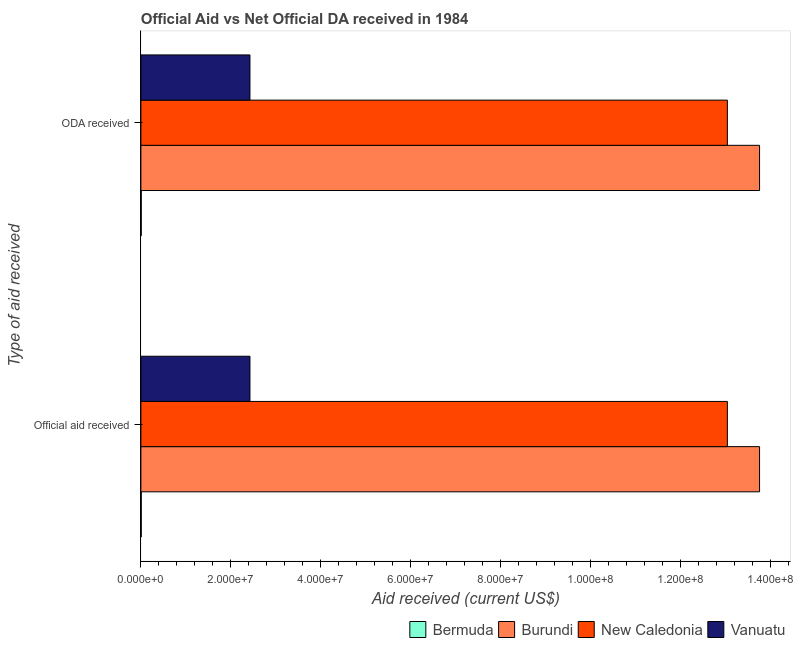How many different coloured bars are there?
Your answer should be very brief. 4. How many groups of bars are there?
Your response must be concise. 2. Are the number of bars per tick equal to the number of legend labels?
Make the answer very short. Yes. What is the label of the 1st group of bars from the top?
Your response must be concise. ODA received. What is the official aid received in New Caledonia?
Give a very brief answer. 1.31e+08. Across all countries, what is the maximum official aid received?
Ensure brevity in your answer.  1.38e+08. Across all countries, what is the minimum oda received?
Your response must be concise. 8.00e+04. In which country was the oda received maximum?
Provide a succinct answer. Burundi. In which country was the oda received minimum?
Offer a very short reply. Bermuda. What is the total oda received in the graph?
Provide a short and direct response. 2.93e+08. What is the difference between the oda received in Bermuda and that in Burundi?
Provide a succinct answer. -1.38e+08. What is the difference between the official aid received in Bermuda and the oda received in Burundi?
Ensure brevity in your answer.  -1.38e+08. What is the average official aid received per country?
Offer a very short reply. 7.31e+07. What is the ratio of the official aid received in Bermuda to that in Vanuatu?
Keep it short and to the point. 0. Is the oda received in Bermuda less than that in New Caledonia?
Provide a short and direct response. Yes. What does the 3rd bar from the top in ODA received represents?
Keep it short and to the point. Burundi. What does the 2nd bar from the bottom in ODA received represents?
Keep it short and to the point. Burundi. How many bars are there?
Make the answer very short. 8. Are all the bars in the graph horizontal?
Offer a very short reply. Yes. Does the graph contain grids?
Your answer should be very brief. No. Where does the legend appear in the graph?
Offer a terse response. Bottom right. How many legend labels are there?
Ensure brevity in your answer.  4. How are the legend labels stacked?
Offer a very short reply. Horizontal. What is the title of the graph?
Offer a terse response. Official Aid vs Net Official DA received in 1984 . What is the label or title of the X-axis?
Your response must be concise. Aid received (current US$). What is the label or title of the Y-axis?
Provide a short and direct response. Type of aid received. What is the Aid received (current US$) of Bermuda in Official aid received?
Ensure brevity in your answer.  8.00e+04. What is the Aid received (current US$) in Burundi in Official aid received?
Make the answer very short. 1.38e+08. What is the Aid received (current US$) in New Caledonia in Official aid received?
Keep it short and to the point. 1.31e+08. What is the Aid received (current US$) of Vanuatu in Official aid received?
Ensure brevity in your answer.  2.43e+07. What is the Aid received (current US$) of Burundi in ODA received?
Keep it short and to the point. 1.38e+08. What is the Aid received (current US$) in New Caledonia in ODA received?
Give a very brief answer. 1.31e+08. What is the Aid received (current US$) in Vanuatu in ODA received?
Your answer should be very brief. 2.43e+07. Across all Type of aid received, what is the maximum Aid received (current US$) in Burundi?
Give a very brief answer. 1.38e+08. Across all Type of aid received, what is the maximum Aid received (current US$) in New Caledonia?
Provide a short and direct response. 1.31e+08. Across all Type of aid received, what is the maximum Aid received (current US$) of Vanuatu?
Your answer should be compact. 2.43e+07. Across all Type of aid received, what is the minimum Aid received (current US$) of Burundi?
Provide a short and direct response. 1.38e+08. Across all Type of aid received, what is the minimum Aid received (current US$) of New Caledonia?
Offer a terse response. 1.31e+08. Across all Type of aid received, what is the minimum Aid received (current US$) of Vanuatu?
Make the answer very short. 2.43e+07. What is the total Aid received (current US$) of Burundi in the graph?
Your answer should be very brief. 2.75e+08. What is the total Aid received (current US$) in New Caledonia in the graph?
Your answer should be compact. 2.61e+08. What is the total Aid received (current US$) in Vanuatu in the graph?
Make the answer very short. 4.85e+07. What is the difference between the Aid received (current US$) of Burundi in Official aid received and that in ODA received?
Give a very brief answer. 0. What is the difference between the Aid received (current US$) of Bermuda in Official aid received and the Aid received (current US$) of Burundi in ODA received?
Your answer should be compact. -1.38e+08. What is the difference between the Aid received (current US$) of Bermuda in Official aid received and the Aid received (current US$) of New Caledonia in ODA received?
Provide a succinct answer. -1.30e+08. What is the difference between the Aid received (current US$) of Bermuda in Official aid received and the Aid received (current US$) of Vanuatu in ODA received?
Your answer should be very brief. -2.42e+07. What is the difference between the Aid received (current US$) in Burundi in Official aid received and the Aid received (current US$) in New Caledonia in ODA received?
Offer a very short reply. 7.16e+06. What is the difference between the Aid received (current US$) of Burundi in Official aid received and the Aid received (current US$) of Vanuatu in ODA received?
Offer a terse response. 1.13e+08. What is the difference between the Aid received (current US$) of New Caledonia in Official aid received and the Aid received (current US$) of Vanuatu in ODA received?
Offer a very short reply. 1.06e+08. What is the average Aid received (current US$) in Burundi per Type of aid received?
Keep it short and to the point. 1.38e+08. What is the average Aid received (current US$) of New Caledonia per Type of aid received?
Your answer should be very brief. 1.31e+08. What is the average Aid received (current US$) in Vanuatu per Type of aid received?
Make the answer very short. 2.43e+07. What is the difference between the Aid received (current US$) in Bermuda and Aid received (current US$) in Burundi in Official aid received?
Your response must be concise. -1.38e+08. What is the difference between the Aid received (current US$) of Bermuda and Aid received (current US$) of New Caledonia in Official aid received?
Ensure brevity in your answer.  -1.30e+08. What is the difference between the Aid received (current US$) of Bermuda and Aid received (current US$) of Vanuatu in Official aid received?
Offer a terse response. -2.42e+07. What is the difference between the Aid received (current US$) of Burundi and Aid received (current US$) of New Caledonia in Official aid received?
Ensure brevity in your answer.  7.16e+06. What is the difference between the Aid received (current US$) of Burundi and Aid received (current US$) of Vanuatu in Official aid received?
Give a very brief answer. 1.13e+08. What is the difference between the Aid received (current US$) in New Caledonia and Aid received (current US$) in Vanuatu in Official aid received?
Your response must be concise. 1.06e+08. What is the difference between the Aid received (current US$) of Bermuda and Aid received (current US$) of Burundi in ODA received?
Keep it short and to the point. -1.38e+08. What is the difference between the Aid received (current US$) of Bermuda and Aid received (current US$) of New Caledonia in ODA received?
Provide a short and direct response. -1.30e+08. What is the difference between the Aid received (current US$) in Bermuda and Aid received (current US$) in Vanuatu in ODA received?
Provide a short and direct response. -2.42e+07. What is the difference between the Aid received (current US$) in Burundi and Aid received (current US$) in New Caledonia in ODA received?
Ensure brevity in your answer.  7.16e+06. What is the difference between the Aid received (current US$) in Burundi and Aid received (current US$) in Vanuatu in ODA received?
Provide a short and direct response. 1.13e+08. What is the difference between the Aid received (current US$) in New Caledonia and Aid received (current US$) in Vanuatu in ODA received?
Your answer should be compact. 1.06e+08. What is the ratio of the Aid received (current US$) of New Caledonia in Official aid received to that in ODA received?
Your answer should be compact. 1. What is the difference between the highest and the second highest Aid received (current US$) in Bermuda?
Make the answer very short. 0. What is the difference between the highest and the second highest Aid received (current US$) in New Caledonia?
Your answer should be very brief. 0. What is the difference between the highest and the second highest Aid received (current US$) of Vanuatu?
Make the answer very short. 0. What is the difference between the highest and the lowest Aid received (current US$) in Bermuda?
Provide a succinct answer. 0. 